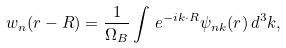<formula> <loc_0><loc_0><loc_500><loc_500>w _ { n } ( { r } - { R } ) = \frac { 1 } { \Omega _ { B } } \int \, e ^ { - i { k } \cdot { R } } \psi _ { n { k } } ( { r } ) \, d ^ { 3 } k ,</formula> 